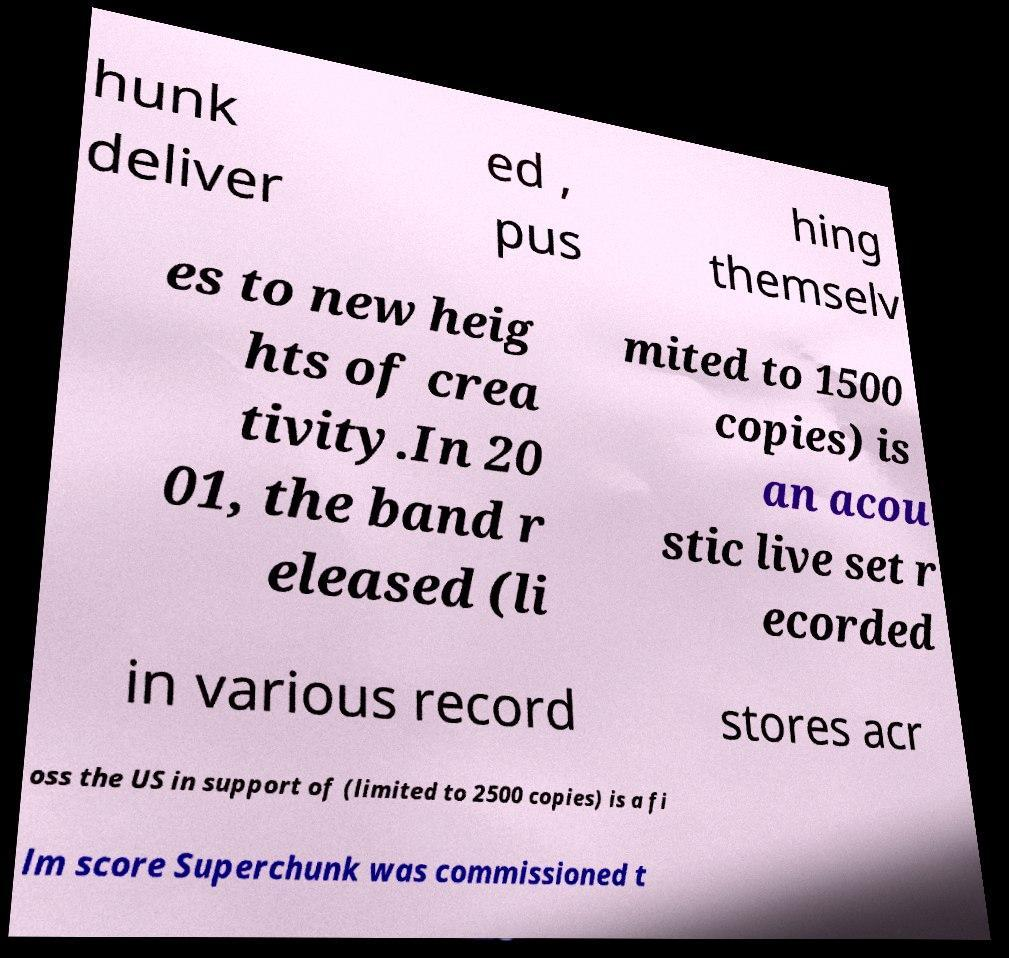Could you extract and type out the text from this image? hunk deliver ed , pus hing themselv es to new heig hts of crea tivity.In 20 01, the band r eleased (li mited to 1500 copies) is an acou stic live set r ecorded in various record stores acr oss the US in support of (limited to 2500 copies) is a fi lm score Superchunk was commissioned t 